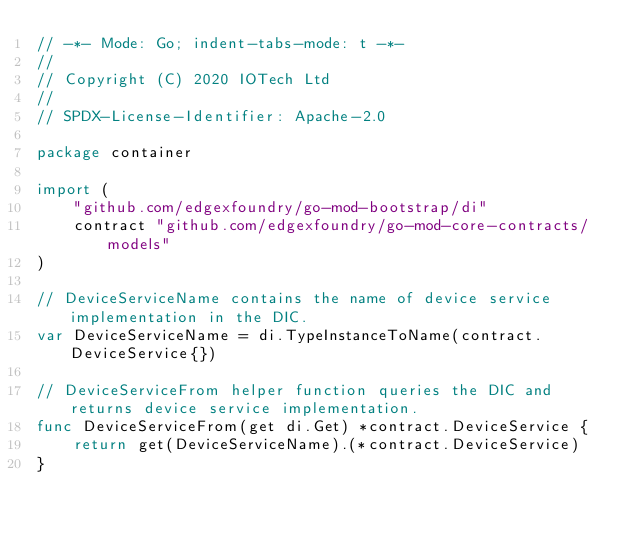Convert code to text. <code><loc_0><loc_0><loc_500><loc_500><_Go_>// -*- Mode: Go; indent-tabs-mode: t -*-
//
// Copyright (C) 2020 IOTech Ltd
//
// SPDX-License-Identifier: Apache-2.0

package container

import (
	"github.com/edgexfoundry/go-mod-bootstrap/di"
	contract "github.com/edgexfoundry/go-mod-core-contracts/models"
)

// DeviceServiceName contains the name of device service implementation in the DIC.
var DeviceServiceName = di.TypeInstanceToName(contract.DeviceService{})

// DeviceServiceFrom helper function queries the DIC and returns device service implementation.
func DeviceServiceFrom(get di.Get) *contract.DeviceService {
	return get(DeviceServiceName).(*contract.DeviceService)
}
</code> 